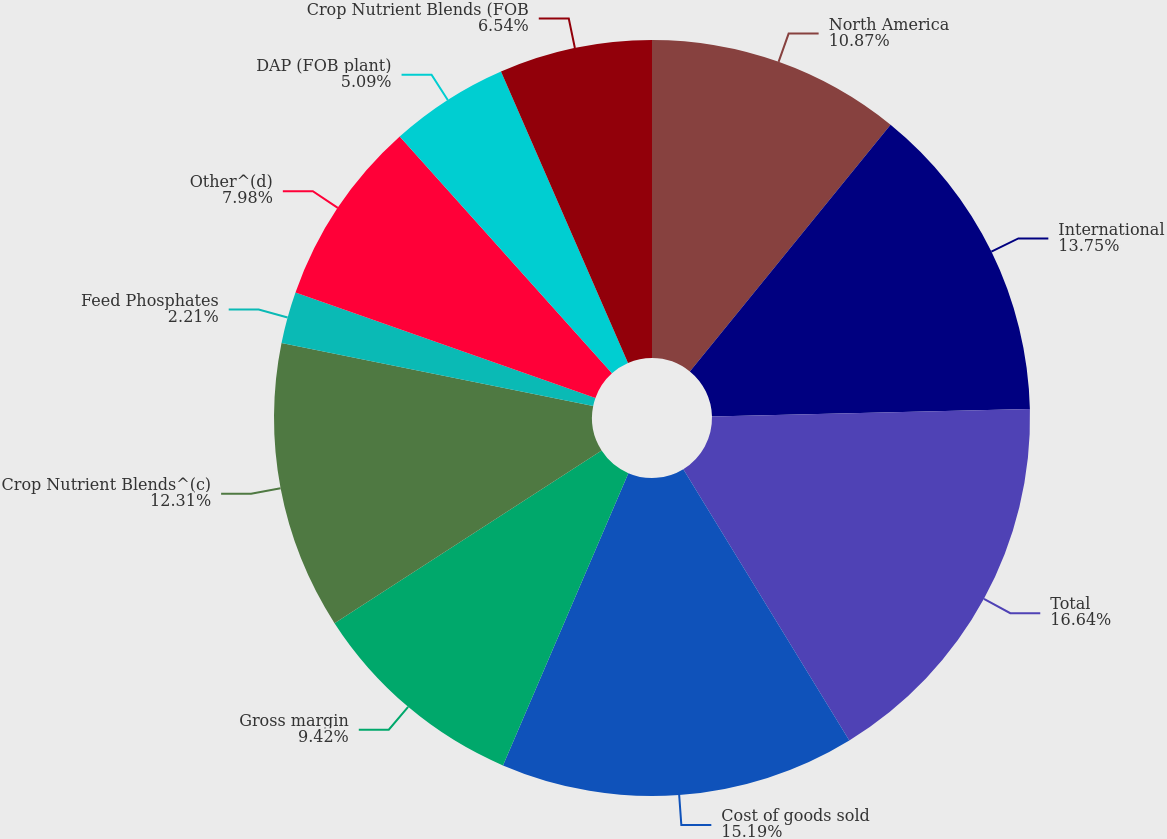Convert chart. <chart><loc_0><loc_0><loc_500><loc_500><pie_chart><fcel>North America<fcel>International<fcel>Total<fcel>Cost of goods sold<fcel>Gross margin<fcel>Crop Nutrient Blends^(c)<fcel>Feed Phosphates<fcel>Other^(d)<fcel>DAP (FOB plant)<fcel>Crop Nutrient Blends (FOB<nl><fcel>10.87%<fcel>13.75%<fcel>16.64%<fcel>15.19%<fcel>9.42%<fcel>12.31%<fcel>2.21%<fcel>7.98%<fcel>5.09%<fcel>6.54%<nl></chart> 